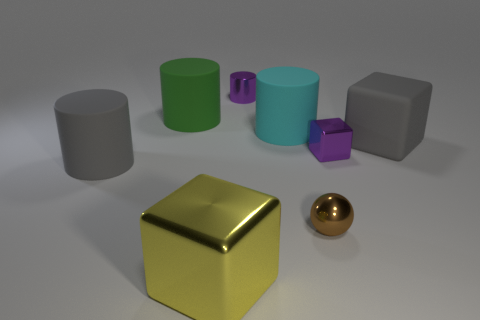Add 2 big cyan objects. How many objects exist? 10 Subtract all blocks. How many objects are left? 5 Subtract all tiny gray shiny objects. Subtract all matte things. How many objects are left? 4 Add 5 large gray things. How many large gray things are left? 7 Add 7 large yellow things. How many large yellow things exist? 8 Subtract 0 cyan cubes. How many objects are left? 8 